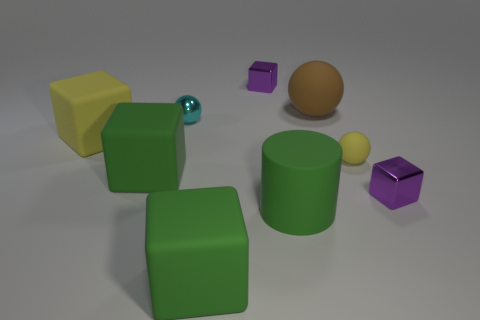Subtract 2 blocks. How many blocks are left? 3 Subtract all tiny spheres. How many spheres are left? 1 Subtract all yellow cubes. How many cubes are left? 4 Subtract all yellow blocks. Subtract all purple spheres. How many blocks are left? 4 Subtract all cylinders. How many objects are left? 8 Subtract 0 red spheres. How many objects are left? 9 Subtract all metallic balls. Subtract all brown matte cubes. How many objects are left? 8 Add 5 purple metal things. How many purple metal things are left? 7 Add 5 cyan things. How many cyan things exist? 6 